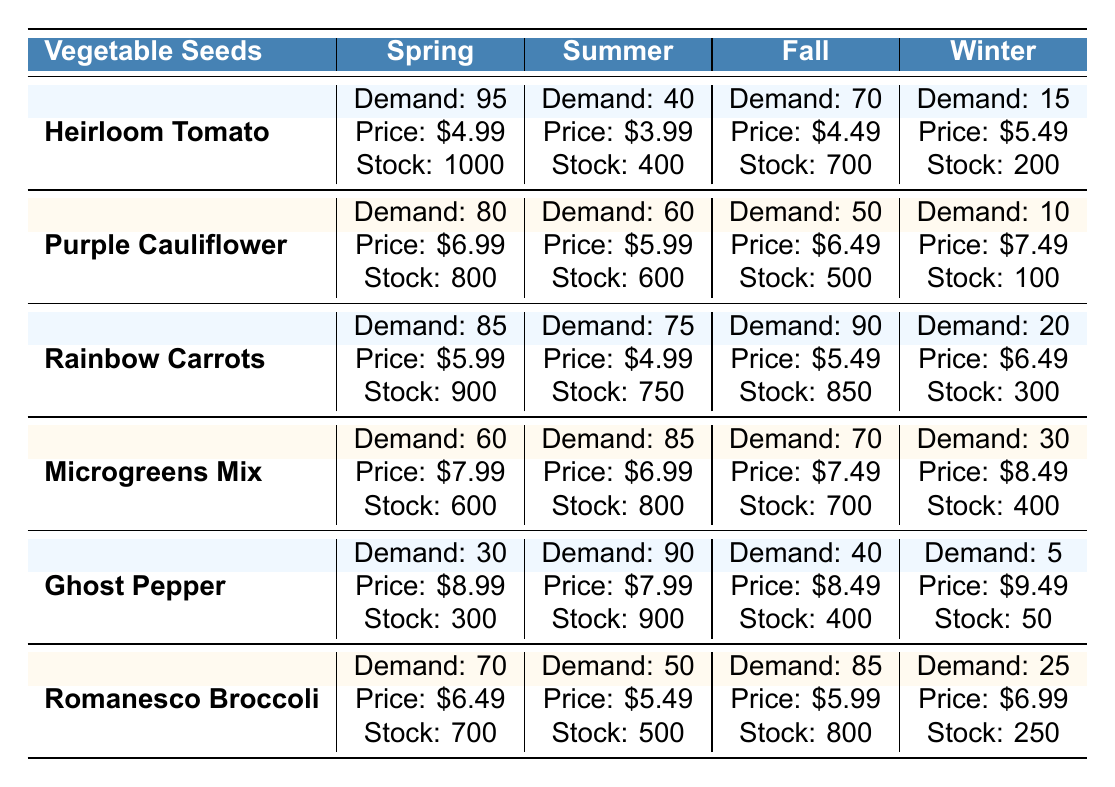What is the highest demand for Heirloom Tomato? The highest demand for Heirloom Tomato is in Spring at 95.
Answer: 95 What is the demand for Microgreens Mix in Winter? The table shows that the demand for Microgreens Mix in Winter is 30.
Answer: 30 Which vegetable has the highest stock level in Summer? The stock levels in Summer are 400 for Heirloom Tomato, 600 for Purple Cauliflower, 750 for Rainbow Carrots, 800 for Microgreens Mix, 900 for Ghost Pepper, and 500 for Romanesco Broccoli. The highest stock level is 900 for Ghost Pepper.
Answer: 900 Calculate the average price per packet for Rainbow Carrots across all seasons. The prices for Rainbow Carrots are $5.99, $4.99, $5.49, and $6.49. The sum is 5.99 + 4.99 + 5.49 + 6.49 = 22.96. Dividing by 4 gives an average of 22.96 / 4 = 5.74.
Answer: 5.74 Is the demand for Ghost Pepper highest in Summer? The demand for Ghost Pepper is 90 in Summer, which is the highest for this vegetable.
Answer: Yes What is the difference in demand between Fall and Spring for Romanesco Broccoli? The demand for Romanesco Broccoli in Fall is 85 and in Spring is 70. The difference is 85 - 70 = 15.
Answer: 15 Which season shows the greatest increase in demand for Rainbow Carrots compared to Winter? The demand for Rainbow Carrots is 90 in Fall, 75 in Summer, and 85 in Spring. Comparing those demands to 20 in Winter, the greatest increase is from Winter to Fall: 90 - 20 = 70.
Answer: 70 Summarize the average stock level for each vegetable across all seasons. The stocks are: Heirloom Tomato (1000 + 400 + 700 + 200) / 4 = 575, Purple Cauliflower (800 + 600 + 500 + 100) / 4 = 502.5, Rainbow Carrots (900 + 750 + 850 + 300) / 4 = 575, Microgreens Mix (600 + 800 + 700 + 400) / 4 = 625, Ghost Pepper (300 + 900 + 400 + 50) / 4 = 412.5, Romanesco Broccoli (700 + 500 + 800 + 250) / 4 = 562.5.
Answer: Heirloom Tomato: 575, Purple Cauliflower: 502.5, Rainbow Carrots: 575, Microgreens Mix: 625, Ghost Pepper: 412.5, Romanesco Broccoli: 562.5 In which season is the stock level for Heirloom Tomato the lowest? The stock levels for Heirloom Tomato are 1000 in Spring, 400 in Summer, 700 in Fall, and 200 in Winter. The lowest is in Winter.
Answer: Winter What vegetable has a demand above 80 in Spring? In Spring, the demands are 95 (Heirloom Tomato), 80 (Purple Cauliflower), 85 (Rainbow Carrots), 60 (Microgreens Mix), 30 (Ghost Pepper), and 70 (Romanesco Broccoli). The vegetables with demand above 80 in Spring are Heirloom Tomato, Purple Cauliflower, and Rainbow Carrots.
Answer: Heirloom Tomato, Purple Cauliflower, Rainbow Carrots 